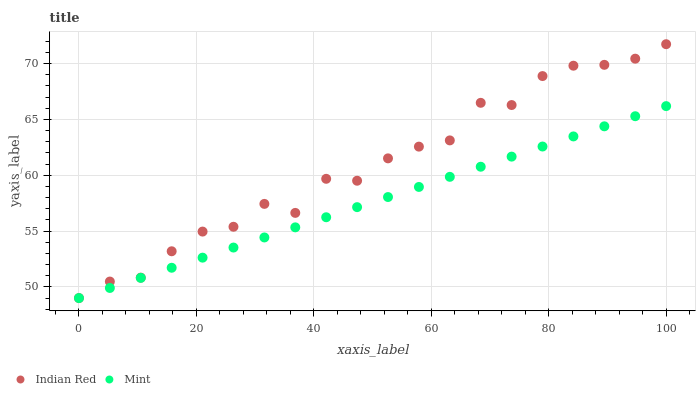Does Mint have the minimum area under the curve?
Answer yes or no. Yes. Does Indian Red have the maximum area under the curve?
Answer yes or no. Yes. Does Indian Red have the minimum area under the curve?
Answer yes or no. No. Is Mint the smoothest?
Answer yes or no. Yes. Is Indian Red the roughest?
Answer yes or no. Yes. Is Indian Red the smoothest?
Answer yes or no. No. Does Mint have the lowest value?
Answer yes or no. Yes. Does Indian Red have the highest value?
Answer yes or no. Yes. Does Indian Red intersect Mint?
Answer yes or no. Yes. Is Indian Red less than Mint?
Answer yes or no. No. Is Indian Red greater than Mint?
Answer yes or no. No. 